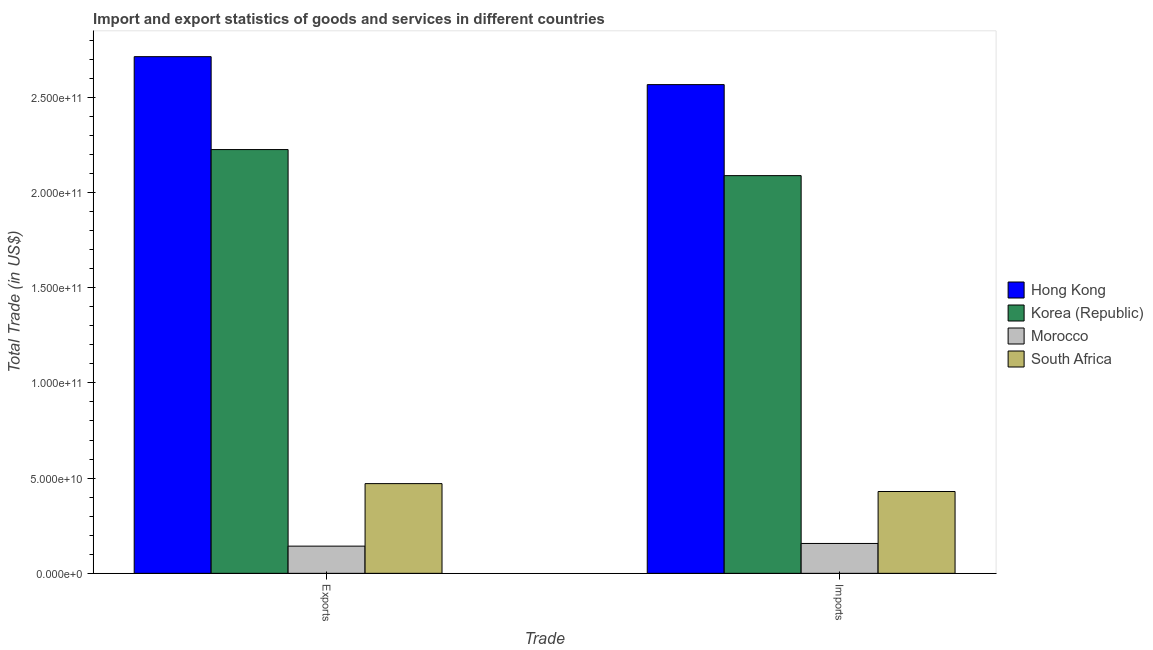How many groups of bars are there?
Your answer should be very brief. 2. How many bars are there on the 2nd tick from the right?
Provide a succinct answer. 4. What is the label of the 1st group of bars from the left?
Make the answer very short. Exports. What is the export of goods and services in South Africa?
Your answer should be compact. 4.71e+1. Across all countries, what is the maximum export of goods and services?
Your answer should be compact. 2.71e+11. Across all countries, what is the minimum imports of goods and services?
Your answer should be very brief. 1.57e+1. In which country was the export of goods and services maximum?
Ensure brevity in your answer.  Hong Kong. In which country was the imports of goods and services minimum?
Your answer should be very brief. Morocco. What is the total export of goods and services in the graph?
Keep it short and to the point. 5.55e+11. What is the difference between the imports of goods and services in Morocco and that in South Africa?
Your response must be concise. -2.73e+1. What is the difference between the export of goods and services in Korea (Republic) and the imports of goods and services in Hong Kong?
Give a very brief answer. -3.41e+1. What is the average imports of goods and services per country?
Offer a very short reply. 1.31e+11. What is the difference between the imports of goods and services and export of goods and services in Morocco?
Make the answer very short. 1.41e+09. What is the ratio of the imports of goods and services in Hong Kong to that in South Africa?
Give a very brief answer. 5.97. What does the 4th bar from the right in Exports represents?
Keep it short and to the point. Hong Kong. Are all the bars in the graph horizontal?
Give a very brief answer. No. Does the graph contain any zero values?
Provide a succinct answer. No. What is the title of the graph?
Provide a succinct answer. Import and export statistics of goods and services in different countries. What is the label or title of the X-axis?
Give a very brief answer. Trade. What is the label or title of the Y-axis?
Ensure brevity in your answer.  Total Trade (in US$). What is the Total Trade (in US$) of Hong Kong in Exports?
Your response must be concise. 2.71e+11. What is the Total Trade (in US$) in Korea (Republic) in Exports?
Ensure brevity in your answer.  2.23e+11. What is the Total Trade (in US$) in Morocco in Exports?
Provide a short and direct response. 1.43e+1. What is the Total Trade (in US$) in South Africa in Exports?
Give a very brief answer. 4.71e+1. What is the Total Trade (in US$) of Hong Kong in Imports?
Make the answer very short. 2.57e+11. What is the Total Trade (in US$) in Korea (Republic) in Imports?
Provide a succinct answer. 2.09e+11. What is the Total Trade (in US$) in Morocco in Imports?
Your response must be concise. 1.57e+1. What is the Total Trade (in US$) in South Africa in Imports?
Provide a short and direct response. 4.30e+1. Across all Trade, what is the maximum Total Trade (in US$) in Hong Kong?
Your answer should be compact. 2.71e+11. Across all Trade, what is the maximum Total Trade (in US$) of Korea (Republic)?
Your answer should be compact. 2.23e+11. Across all Trade, what is the maximum Total Trade (in US$) of Morocco?
Give a very brief answer. 1.57e+1. Across all Trade, what is the maximum Total Trade (in US$) in South Africa?
Your answer should be very brief. 4.71e+1. Across all Trade, what is the minimum Total Trade (in US$) in Hong Kong?
Give a very brief answer. 2.57e+11. Across all Trade, what is the minimum Total Trade (in US$) in Korea (Republic)?
Keep it short and to the point. 2.09e+11. Across all Trade, what is the minimum Total Trade (in US$) of Morocco?
Make the answer very short. 1.43e+1. Across all Trade, what is the minimum Total Trade (in US$) of South Africa?
Your response must be concise. 4.30e+1. What is the total Total Trade (in US$) in Hong Kong in the graph?
Make the answer very short. 5.28e+11. What is the total Total Trade (in US$) in Korea (Republic) in the graph?
Make the answer very short. 4.31e+11. What is the total Total Trade (in US$) in Morocco in the graph?
Provide a succinct answer. 3.00e+1. What is the total Total Trade (in US$) in South Africa in the graph?
Give a very brief answer. 9.01e+1. What is the difference between the Total Trade (in US$) of Hong Kong in Exports and that in Imports?
Ensure brevity in your answer.  1.47e+1. What is the difference between the Total Trade (in US$) of Korea (Republic) in Exports and that in Imports?
Keep it short and to the point. 1.37e+1. What is the difference between the Total Trade (in US$) of Morocco in Exports and that in Imports?
Your answer should be compact. -1.41e+09. What is the difference between the Total Trade (in US$) in South Africa in Exports and that in Imports?
Ensure brevity in your answer.  4.15e+09. What is the difference between the Total Trade (in US$) in Hong Kong in Exports and the Total Trade (in US$) in Korea (Republic) in Imports?
Make the answer very short. 6.25e+1. What is the difference between the Total Trade (in US$) of Hong Kong in Exports and the Total Trade (in US$) of Morocco in Imports?
Provide a succinct answer. 2.56e+11. What is the difference between the Total Trade (in US$) in Hong Kong in Exports and the Total Trade (in US$) in South Africa in Imports?
Provide a short and direct response. 2.28e+11. What is the difference between the Total Trade (in US$) of Korea (Republic) in Exports and the Total Trade (in US$) of Morocco in Imports?
Make the answer very short. 2.07e+11. What is the difference between the Total Trade (in US$) of Korea (Republic) in Exports and the Total Trade (in US$) of South Africa in Imports?
Ensure brevity in your answer.  1.80e+11. What is the difference between the Total Trade (in US$) of Morocco in Exports and the Total Trade (in US$) of South Africa in Imports?
Ensure brevity in your answer.  -2.87e+1. What is the average Total Trade (in US$) of Hong Kong per Trade?
Ensure brevity in your answer.  2.64e+11. What is the average Total Trade (in US$) of Korea (Republic) per Trade?
Ensure brevity in your answer.  2.16e+11. What is the average Total Trade (in US$) in Morocco per Trade?
Provide a short and direct response. 1.50e+1. What is the average Total Trade (in US$) of South Africa per Trade?
Provide a succinct answer. 4.50e+1. What is the difference between the Total Trade (in US$) in Hong Kong and Total Trade (in US$) in Korea (Republic) in Exports?
Your answer should be very brief. 4.88e+1. What is the difference between the Total Trade (in US$) of Hong Kong and Total Trade (in US$) of Morocco in Exports?
Ensure brevity in your answer.  2.57e+11. What is the difference between the Total Trade (in US$) in Hong Kong and Total Trade (in US$) in South Africa in Exports?
Provide a short and direct response. 2.24e+11. What is the difference between the Total Trade (in US$) of Korea (Republic) and Total Trade (in US$) of Morocco in Exports?
Make the answer very short. 2.08e+11. What is the difference between the Total Trade (in US$) in Korea (Republic) and Total Trade (in US$) in South Africa in Exports?
Make the answer very short. 1.75e+11. What is the difference between the Total Trade (in US$) in Morocco and Total Trade (in US$) in South Africa in Exports?
Make the answer very short. -3.28e+1. What is the difference between the Total Trade (in US$) in Hong Kong and Total Trade (in US$) in Korea (Republic) in Imports?
Keep it short and to the point. 4.78e+1. What is the difference between the Total Trade (in US$) of Hong Kong and Total Trade (in US$) of Morocco in Imports?
Your answer should be compact. 2.41e+11. What is the difference between the Total Trade (in US$) in Hong Kong and Total Trade (in US$) in South Africa in Imports?
Provide a short and direct response. 2.14e+11. What is the difference between the Total Trade (in US$) of Korea (Republic) and Total Trade (in US$) of Morocco in Imports?
Give a very brief answer. 1.93e+11. What is the difference between the Total Trade (in US$) in Korea (Republic) and Total Trade (in US$) in South Africa in Imports?
Your answer should be compact. 1.66e+11. What is the difference between the Total Trade (in US$) of Morocco and Total Trade (in US$) of South Africa in Imports?
Ensure brevity in your answer.  -2.73e+1. What is the ratio of the Total Trade (in US$) of Hong Kong in Exports to that in Imports?
Provide a succinct answer. 1.06. What is the ratio of the Total Trade (in US$) of Korea (Republic) in Exports to that in Imports?
Your response must be concise. 1.07. What is the ratio of the Total Trade (in US$) of Morocco in Exports to that in Imports?
Ensure brevity in your answer.  0.91. What is the ratio of the Total Trade (in US$) of South Africa in Exports to that in Imports?
Give a very brief answer. 1.1. What is the difference between the highest and the second highest Total Trade (in US$) in Hong Kong?
Ensure brevity in your answer.  1.47e+1. What is the difference between the highest and the second highest Total Trade (in US$) in Korea (Republic)?
Your response must be concise. 1.37e+1. What is the difference between the highest and the second highest Total Trade (in US$) of Morocco?
Give a very brief answer. 1.41e+09. What is the difference between the highest and the second highest Total Trade (in US$) in South Africa?
Provide a short and direct response. 4.15e+09. What is the difference between the highest and the lowest Total Trade (in US$) in Hong Kong?
Your answer should be compact. 1.47e+1. What is the difference between the highest and the lowest Total Trade (in US$) of Korea (Republic)?
Give a very brief answer. 1.37e+1. What is the difference between the highest and the lowest Total Trade (in US$) of Morocco?
Offer a terse response. 1.41e+09. What is the difference between the highest and the lowest Total Trade (in US$) in South Africa?
Your answer should be compact. 4.15e+09. 